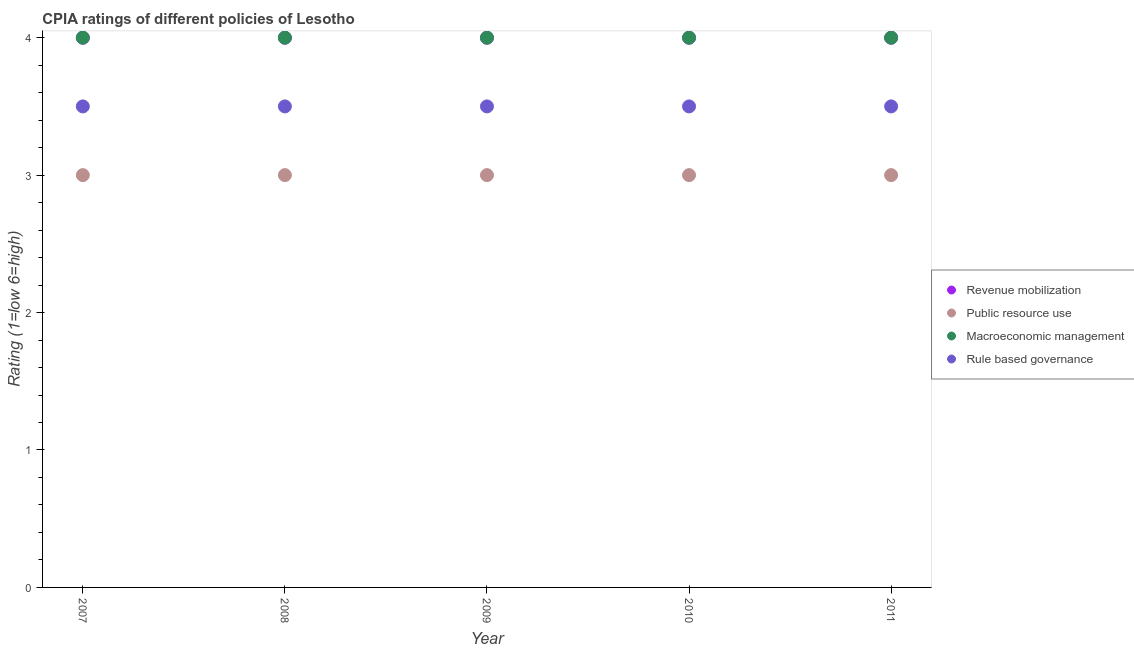What is the cpia rating of rule based governance in 2010?
Your answer should be compact. 3.5. Across all years, what is the minimum cpia rating of macroeconomic management?
Provide a short and direct response. 4. What is the difference between the cpia rating of public resource use in 2010 and that in 2011?
Keep it short and to the point. 0. What is the average cpia rating of revenue mobilization per year?
Provide a succinct answer. 4. In the year 2007, what is the difference between the cpia rating of revenue mobilization and cpia rating of public resource use?
Make the answer very short. 1. In how many years, is the cpia rating of macroeconomic management greater than 3?
Your response must be concise. 5. What is the difference between the highest and the second highest cpia rating of macroeconomic management?
Give a very brief answer. 0. Does the cpia rating of macroeconomic management monotonically increase over the years?
Your response must be concise. No. How many years are there in the graph?
Offer a terse response. 5. What is the difference between two consecutive major ticks on the Y-axis?
Ensure brevity in your answer.  1. Does the graph contain any zero values?
Provide a short and direct response. No. Where does the legend appear in the graph?
Ensure brevity in your answer.  Center right. How many legend labels are there?
Make the answer very short. 4. What is the title of the graph?
Keep it short and to the point. CPIA ratings of different policies of Lesotho. What is the label or title of the X-axis?
Ensure brevity in your answer.  Year. What is the Rating (1=low 6=high) in Macroeconomic management in 2007?
Ensure brevity in your answer.  4. What is the Rating (1=low 6=high) in Rule based governance in 2007?
Keep it short and to the point. 3.5. What is the Rating (1=low 6=high) in Public resource use in 2008?
Give a very brief answer. 3. What is the Rating (1=low 6=high) in Macroeconomic management in 2008?
Your response must be concise. 4. What is the Rating (1=low 6=high) in Revenue mobilization in 2009?
Offer a very short reply. 4. What is the Rating (1=low 6=high) of Rule based governance in 2009?
Give a very brief answer. 3.5. Across all years, what is the maximum Rating (1=low 6=high) in Macroeconomic management?
Make the answer very short. 4. Across all years, what is the minimum Rating (1=low 6=high) in Revenue mobilization?
Make the answer very short. 4. Across all years, what is the minimum Rating (1=low 6=high) in Rule based governance?
Provide a succinct answer. 3.5. What is the total Rating (1=low 6=high) in Macroeconomic management in the graph?
Provide a short and direct response. 20. What is the difference between the Rating (1=low 6=high) of Public resource use in 2007 and that in 2008?
Your answer should be very brief. 0. What is the difference between the Rating (1=low 6=high) of Macroeconomic management in 2007 and that in 2008?
Give a very brief answer. 0. What is the difference between the Rating (1=low 6=high) in Public resource use in 2007 and that in 2009?
Give a very brief answer. 0. What is the difference between the Rating (1=low 6=high) of Macroeconomic management in 2007 and that in 2009?
Ensure brevity in your answer.  0. What is the difference between the Rating (1=low 6=high) of Public resource use in 2007 and that in 2010?
Ensure brevity in your answer.  0. What is the difference between the Rating (1=low 6=high) of Macroeconomic management in 2007 and that in 2010?
Keep it short and to the point. 0. What is the difference between the Rating (1=low 6=high) of Rule based governance in 2007 and that in 2010?
Keep it short and to the point. 0. What is the difference between the Rating (1=low 6=high) of Revenue mobilization in 2007 and that in 2011?
Your answer should be compact. 0. What is the difference between the Rating (1=low 6=high) in Public resource use in 2007 and that in 2011?
Offer a terse response. 0. What is the difference between the Rating (1=low 6=high) in Rule based governance in 2007 and that in 2011?
Provide a short and direct response. 0. What is the difference between the Rating (1=low 6=high) in Macroeconomic management in 2008 and that in 2009?
Your response must be concise. 0. What is the difference between the Rating (1=low 6=high) in Rule based governance in 2008 and that in 2009?
Give a very brief answer. 0. What is the difference between the Rating (1=low 6=high) in Revenue mobilization in 2008 and that in 2010?
Your answer should be compact. 0. What is the difference between the Rating (1=low 6=high) in Public resource use in 2008 and that in 2010?
Ensure brevity in your answer.  0. What is the difference between the Rating (1=low 6=high) in Revenue mobilization in 2008 and that in 2011?
Offer a very short reply. 0. What is the difference between the Rating (1=low 6=high) in Public resource use in 2009 and that in 2010?
Give a very brief answer. 0. What is the difference between the Rating (1=low 6=high) in Rule based governance in 2009 and that in 2010?
Provide a succinct answer. 0. What is the difference between the Rating (1=low 6=high) of Revenue mobilization in 2009 and that in 2011?
Your answer should be very brief. 0. What is the difference between the Rating (1=low 6=high) of Public resource use in 2009 and that in 2011?
Your answer should be compact. 0. What is the difference between the Rating (1=low 6=high) in Macroeconomic management in 2009 and that in 2011?
Keep it short and to the point. 0. What is the difference between the Rating (1=low 6=high) in Rule based governance in 2010 and that in 2011?
Keep it short and to the point. 0. What is the difference between the Rating (1=low 6=high) in Public resource use in 2007 and the Rating (1=low 6=high) in Macroeconomic management in 2008?
Provide a succinct answer. -1. What is the difference between the Rating (1=low 6=high) in Revenue mobilization in 2007 and the Rating (1=low 6=high) in Public resource use in 2009?
Give a very brief answer. 1. What is the difference between the Rating (1=low 6=high) of Revenue mobilization in 2007 and the Rating (1=low 6=high) of Macroeconomic management in 2009?
Ensure brevity in your answer.  0. What is the difference between the Rating (1=low 6=high) of Revenue mobilization in 2007 and the Rating (1=low 6=high) of Rule based governance in 2009?
Make the answer very short. 0.5. What is the difference between the Rating (1=low 6=high) in Public resource use in 2007 and the Rating (1=low 6=high) in Rule based governance in 2009?
Provide a succinct answer. -0.5. What is the difference between the Rating (1=low 6=high) in Public resource use in 2007 and the Rating (1=low 6=high) in Rule based governance in 2010?
Keep it short and to the point. -0.5. What is the difference between the Rating (1=low 6=high) of Revenue mobilization in 2007 and the Rating (1=low 6=high) of Public resource use in 2011?
Your response must be concise. 1. What is the difference between the Rating (1=low 6=high) in Revenue mobilization in 2007 and the Rating (1=low 6=high) in Macroeconomic management in 2011?
Keep it short and to the point. 0. What is the difference between the Rating (1=low 6=high) in Revenue mobilization in 2007 and the Rating (1=low 6=high) in Rule based governance in 2011?
Provide a short and direct response. 0.5. What is the difference between the Rating (1=low 6=high) in Public resource use in 2007 and the Rating (1=low 6=high) in Rule based governance in 2011?
Give a very brief answer. -0.5. What is the difference between the Rating (1=low 6=high) of Revenue mobilization in 2008 and the Rating (1=low 6=high) of Macroeconomic management in 2009?
Provide a succinct answer. 0. What is the difference between the Rating (1=low 6=high) of Revenue mobilization in 2008 and the Rating (1=low 6=high) of Rule based governance in 2009?
Keep it short and to the point. 0.5. What is the difference between the Rating (1=low 6=high) of Public resource use in 2008 and the Rating (1=low 6=high) of Rule based governance in 2009?
Make the answer very short. -0.5. What is the difference between the Rating (1=low 6=high) of Revenue mobilization in 2008 and the Rating (1=low 6=high) of Macroeconomic management in 2010?
Your response must be concise. 0. What is the difference between the Rating (1=low 6=high) in Revenue mobilization in 2008 and the Rating (1=low 6=high) in Rule based governance in 2010?
Offer a very short reply. 0.5. What is the difference between the Rating (1=low 6=high) in Revenue mobilization in 2008 and the Rating (1=low 6=high) in Macroeconomic management in 2011?
Give a very brief answer. 0. What is the difference between the Rating (1=low 6=high) of Revenue mobilization in 2008 and the Rating (1=low 6=high) of Rule based governance in 2011?
Provide a short and direct response. 0.5. What is the difference between the Rating (1=low 6=high) of Macroeconomic management in 2008 and the Rating (1=low 6=high) of Rule based governance in 2011?
Ensure brevity in your answer.  0.5. What is the difference between the Rating (1=low 6=high) in Revenue mobilization in 2009 and the Rating (1=low 6=high) in Public resource use in 2010?
Your answer should be very brief. 1. What is the difference between the Rating (1=low 6=high) of Revenue mobilization in 2009 and the Rating (1=low 6=high) of Macroeconomic management in 2010?
Provide a short and direct response. 0. What is the difference between the Rating (1=low 6=high) in Revenue mobilization in 2009 and the Rating (1=low 6=high) in Rule based governance in 2010?
Your response must be concise. 0.5. What is the difference between the Rating (1=low 6=high) in Public resource use in 2009 and the Rating (1=low 6=high) in Macroeconomic management in 2010?
Provide a succinct answer. -1. What is the difference between the Rating (1=low 6=high) in Macroeconomic management in 2009 and the Rating (1=low 6=high) in Rule based governance in 2010?
Ensure brevity in your answer.  0.5. What is the difference between the Rating (1=low 6=high) of Public resource use in 2009 and the Rating (1=low 6=high) of Macroeconomic management in 2011?
Your response must be concise. -1. What is the difference between the Rating (1=low 6=high) in Revenue mobilization in 2010 and the Rating (1=low 6=high) in Public resource use in 2011?
Make the answer very short. 1. What is the difference between the Rating (1=low 6=high) in Revenue mobilization in 2010 and the Rating (1=low 6=high) in Macroeconomic management in 2011?
Offer a very short reply. 0. What is the difference between the Rating (1=low 6=high) in Public resource use in 2010 and the Rating (1=low 6=high) in Macroeconomic management in 2011?
Make the answer very short. -1. What is the average Rating (1=low 6=high) of Public resource use per year?
Ensure brevity in your answer.  3. What is the average Rating (1=low 6=high) in Macroeconomic management per year?
Make the answer very short. 4. In the year 2007, what is the difference between the Rating (1=low 6=high) of Revenue mobilization and Rating (1=low 6=high) of Macroeconomic management?
Ensure brevity in your answer.  0. In the year 2007, what is the difference between the Rating (1=low 6=high) in Revenue mobilization and Rating (1=low 6=high) in Rule based governance?
Your answer should be compact. 0.5. In the year 2007, what is the difference between the Rating (1=low 6=high) of Macroeconomic management and Rating (1=low 6=high) of Rule based governance?
Your answer should be compact. 0.5. In the year 2008, what is the difference between the Rating (1=low 6=high) of Public resource use and Rating (1=low 6=high) of Macroeconomic management?
Your answer should be very brief. -1. In the year 2009, what is the difference between the Rating (1=low 6=high) in Revenue mobilization and Rating (1=low 6=high) in Public resource use?
Offer a terse response. 1. In the year 2009, what is the difference between the Rating (1=low 6=high) of Revenue mobilization and Rating (1=low 6=high) of Macroeconomic management?
Your response must be concise. 0. In the year 2009, what is the difference between the Rating (1=low 6=high) of Public resource use and Rating (1=low 6=high) of Rule based governance?
Offer a terse response. -0.5. In the year 2010, what is the difference between the Rating (1=low 6=high) in Revenue mobilization and Rating (1=low 6=high) in Public resource use?
Your answer should be very brief. 1. In the year 2010, what is the difference between the Rating (1=low 6=high) of Revenue mobilization and Rating (1=low 6=high) of Macroeconomic management?
Ensure brevity in your answer.  0. In the year 2010, what is the difference between the Rating (1=low 6=high) in Public resource use and Rating (1=low 6=high) in Macroeconomic management?
Your answer should be compact. -1. In the year 2010, what is the difference between the Rating (1=low 6=high) of Public resource use and Rating (1=low 6=high) of Rule based governance?
Provide a succinct answer. -0.5. In the year 2011, what is the difference between the Rating (1=low 6=high) of Revenue mobilization and Rating (1=low 6=high) of Public resource use?
Offer a very short reply. 1. In the year 2011, what is the difference between the Rating (1=low 6=high) in Revenue mobilization and Rating (1=low 6=high) in Macroeconomic management?
Provide a short and direct response. 0. In the year 2011, what is the difference between the Rating (1=low 6=high) of Revenue mobilization and Rating (1=low 6=high) of Rule based governance?
Your answer should be very brief. 0.5. In the year 2011, what is the difference between the Rating (1=low 6=high) in Public resource use and Rating (1=low 6=high) in Rule based governance?
Offer a very short reply. -0.5. What is the ratio of the Rating (1=low 6=high) in Revenue mobilization in 2007 to that in 2008?
Give a very brief answer. 1. What is the ratio of the Rating (1=low 6=high) in Rule based governance in 2007 to that in 2008?
Your response must be concise. 1. What is the ratio of the Rating (1=low 6=high) in Revenue mobilization in 2007 to that in 2010?
Keep it short and to the point. 1. What is the ratio of the Rating (1=low 6=high) of Public resource use in 2007 to that in 2010?
Make the answer very short. 1. What is the ratio of the Rating (1=low 6=high) in Macroeconomic management in 2007 to that in 2010?
Offer a terse response. 1. What is the ratio of the Rating (1=low 6=high) in Public resource use in 2007 to that in 2011?
Provide a short and direct response. 1. What is the ratio of the Rating (1=low 6=high) in Macroeconomic management in 2007 to that in 2011?
Provide a short and direct response. 1. What is the ratio of the Rating (1=low 6=high) in Public resource use in 2008 to that in 2009?
Offer a very short reply. 1. What is the ratio of the Rating (1=low 6=high) in Macroeconomic management in 2008 to that in 2009?
Offer a very short reply. 1. What is the ratio of the Rating (1=low 6=high) in Rule based governance in 2008 to that in 2009?
Make the answer very short. 1. What is the ratio of the Rating (1=low 6=high) of Public resource use in 2008 to that in 2010?
Provide a short and direct response. 1. What is the ratio of the Rating (1=low 6=high) in Macroeconomic management in 2008 to that in 2010?
Offer a terse response. 1. What is the ratio of the Rating (1=low 6=high) of Rule based governance in 2008 to that in 2010?
Your answer should be compact. 1. What is the ratio of the Rating (1=low 6=high) of Revenue mobilization in 2008 to that in 2011?
Your response must be concise. 1. What is the ratio of the Rating (1=low 6=high) in Public resource use in 2008 to that in 2011?
Offer a very short reply. 1. What is the ratio of the Rating (1=low 6=high) of Macroeconomic management in 2008 to that in 2011?
Keep it short and to the point. 1. What is the ratio of the Rating (1=low 6=high) of Revenue mobilization in 2009 to that in 2010?
Your answer should be very brief. 1. What is the ratio of the Rating (1=low 6=high) in Public resource use in 2009 to that in 2010?
Your answer should be compact. 1. What is the ratio of the Rating (1=low 6=high) of Macroeconomic management in 2009 to that in 2010?
Offer a terse response. 1. What is the ratio of the Rating (1=low 6=high) in Rule based governance in 2009 to that in 2010?
Your response must be concise. 1. What is the ratio of the Rating (1=low 6=high) of Revenue mobilization in 2009 to that in 2011?
Provide a short and direct response. 1. What is the ratio of the Rating (1=low 6=high) in Macroeconomic management in 2009 to that in 2011?
Make the answer very short. 1. What is the ratio of the Rating (1=low 6=high) in Public resource use in 2010 to that in 2011?
Your answer should be compact. 1. What is the difference between the highest and the second highest Rating (1=low 6=high) of Revenue mobilization?
Provide a short and direct response. 0. What is the difference between the highest and the second highest Rating (1=low 6=high) of Macroeconomic management?
Give a very brief answer. 0. What is the difference between the highest and the lowest Rating (1=low 6=high) of Revenue mobilization?
Keep it short and to the point. 0. What is the difference between the highest and the lowest Rating (1=low 6=high) of Public resource use?
Keep it short and to the point. 0. 